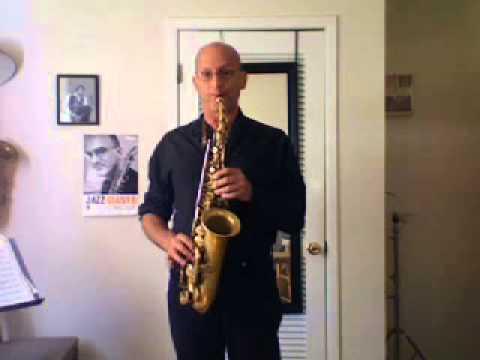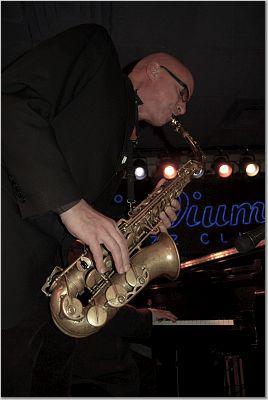The first image is the image on the left, the second image is the image on the right. Given the left and right images, does the statement "Each image shows a man with the mouthpiece of a brass-colored saxophone in his mouth." hold true? Answer yes or no. Yes. 